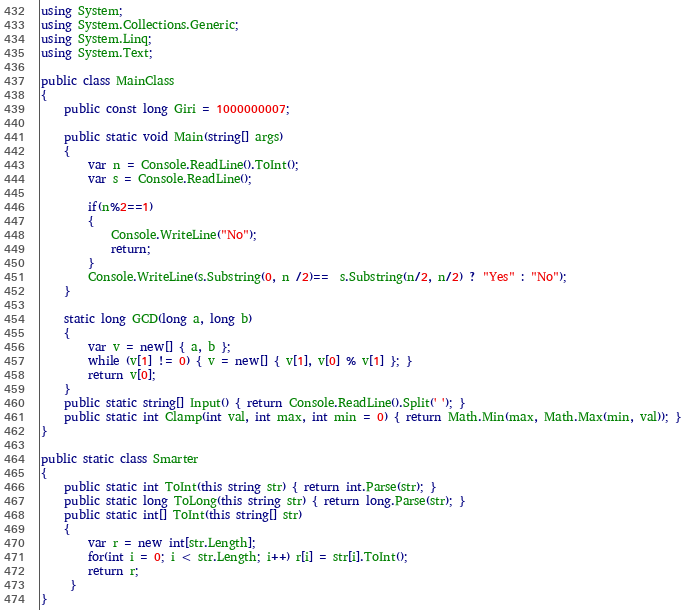<code> <loc_0><loc_0><loc_500><loc_500><_C#_>using System;
using System.Collections.Generic;
using System.Linq;
using System.Text;

public class MainClass
{
	public const long Giri = 1000000007;
	
	public static void Main(string[] args)
	{
		var n = Console.ReadLine().ToInt();
		var s = Console.ReadLine();
		
		if(n%2==1)
		{
			Console.WriteLine("No");
			return;
		}
		Console.WriteLine(s.Substring(0, n /2)==  s.Substring(n/2, n/2) ? "Yes" : "No");
	}
	
	static long GCD(long a, long b)
	{
		var v = new[] { a, b };
		while (v[1] != 0) { v = new[] { v[1], v[0] % v[1] }; }
		return v[0];
	}
	public static string[] Input() { return Console.ReadLine().Split(' '); }
	public static int Clamp(int val, int max, int min = 0) { return Math.Min(max, Math.Max(min, val)); }
}

public static class Smarter
{
	public static int ToInt(this string str) { return int.Parse(str); }
	public static long ToLong(this string str) { return long.Parse(str); }
	public static int[] ToInt(this string[] str)
	{
		var r = new int[str.Length];
		for(int i = 0; i < str.Length; i++) r[i] = str[i].ToInt();
		return r;
	 }
}

</code> 